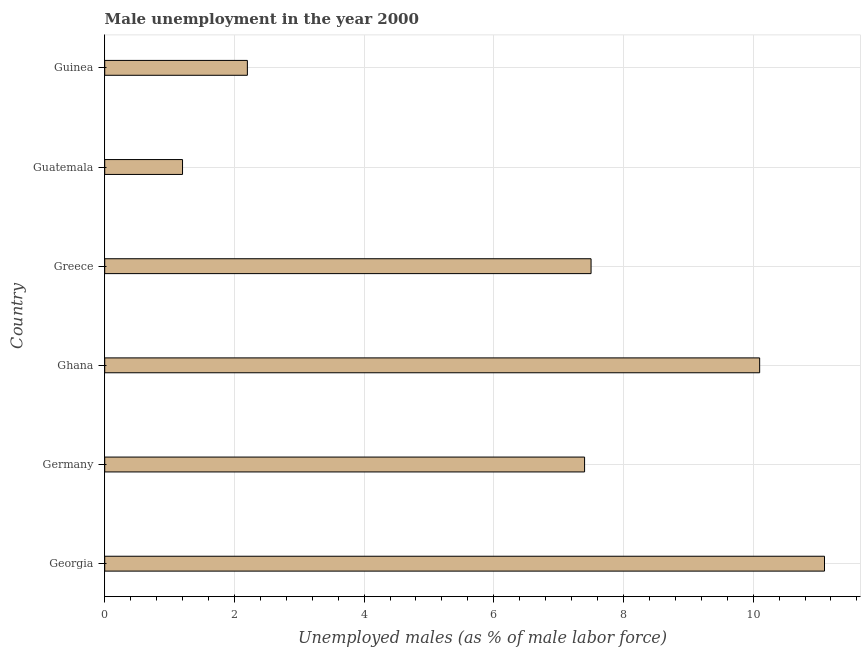Does the graph contain grids?
Offer a terse response. Yes. What is the title of the graph?
Provide a succinct answer. Male unemployment in the year 2000. What is the label or title of the X-axis?
Make the answer very short. Unemployed males (as % of male labor force). What is the unemployed males population in Guinea?
Give a very brief answer. 2.2. Across all countries, what is the maximum unemployed males population?
Keep it short and to the point. 11.1. Across all countries, what is the minimum unemployed males population?
Your answer should be very brief. 1.2. In which country was the unemployed males population maximum?
Offer a very short reply. Georgia. In which country was the unemployed males population minimum?
Offer a terse response. Guatemala. What is the sum of the unemployed males population?
Offer a very short reply. 39.5. What is the average unemployed males population per country?
Your answer should be compact. 6.58. What is the median unemployed males population?
Make the answer very short. 7.45. What is the ratio of the unemployed males population in Georgia to that in Greece?
Your answer should be very brief. 1.48. Is the unemployed males population in Germany less than that in Greece?
Keep it short and to the point. Yes. Is the difference between the unemployed males population in Greece and Guinea greater than the difference between any two countries?
Offer a terse response. No. What is the difference between the highest and the second highest unemployed males population?
Provide a succinct answer. 1. What is the difference between the highest and the lowest unemployed males population?
Ensure brevity in your answer.  9.9. What is the difference between two consecutive major ticks on the X-axis?
Keep it short and to the point. 2. Are the values on the major ticks of X-axis written in scientific E-notation?
Your response must be concise. No. What is the Unemployed males (as % of male labor force) in Georgia?
Make the answer very short. 11.1. What is the Unemployed males (as % of male labor force) in Germany?
Your response must be concise. 7.4. What is the Unemployed males (as % of male labor force) in Ghana?
Offer a very short reply. 10.1. What is the Unemployed males (as % of male labor force) of Greece?
Give a very brief answer. 7.5. What is the Unemployed males (as % of male labor force) in Guatemala?
Your response must be concise. 1.2. What is the Unemployed males (as % of male labor force) in Guinea?
Make the answer very short. 2.2. What is the difference between the Unemployed males (as % of male labor force) in Georgia and Guatemala?
Provide a short and direct response. 9.9. What is the difference between the Unemployed males (as % of male labor force) in Georgia and Guinea?
Make the answer very short. 8.9. What is the difference between the Unemployed males (as % of male labor force) in Ghana and Greece?
Make the answer very short. 2.6. What is the difference between the Unemployed males (as % of male labor force) in Ghana and Guatemala?
Your answer should be compact. 8.9. What is the ratio of the Unemployed males (as % of male labor force) in Georgia to that in Ghana?
Your answer should be compact. 1.1. What is the ratio of the Unemployed males (as % of male labor force) in Georgia to that in Greece?
Give a very brief answer. 1.48. What is the ratio of the Unemployed males (as % of male labor force) in Georgia to that in Guatemala?
Give a very brief answer. 9.25. What is the ratio of the Unemployed males (as % of male labor force) in Georgia to that in Guinea?
Give a very brief answer. 5.04. What is the ratio of the Unemployed males (as % of male labor force) in Germany to that in Ghana?
Provide a short and direct response. 0.73. What is the ratio of the Unemployed males (as % of male labor force) in Germany to that in Guatemala?
Ensure brevity in your answer.  6.17. What is the ratio of the Unemployed males (as % of male labor force) in Germany to that in Guinea?
Your response must be concise. 3.36. What is the ratio of the Unemployed males (as % of male labor force) in Ghana to that in Greece?
Offer a terse response. 1.35. What is the ratio of the Unemployed males (as % of male labor force) in Ghana to that in Guatemala?
Your answer should be compact. 8.42. What is the ratio of the Unemployed males (as % of male labor force) in Ghana to that in Guinea?
Offer a terse response. 4.59. What is the ratio of the Unemployed males (as % of male labor force) in Greece to that in Guatemala?
Your response must be concise. 6.25. What is the ratio of the Unemployed males (as % of male labor force) in Greece to that in Guinea?
Provide a succinct answer. 3.41. What is the ratio of the Unemployed males (as % of male labor force) in Guatemala to that in Guinea?
Provide a succinct answer. 0.55. 